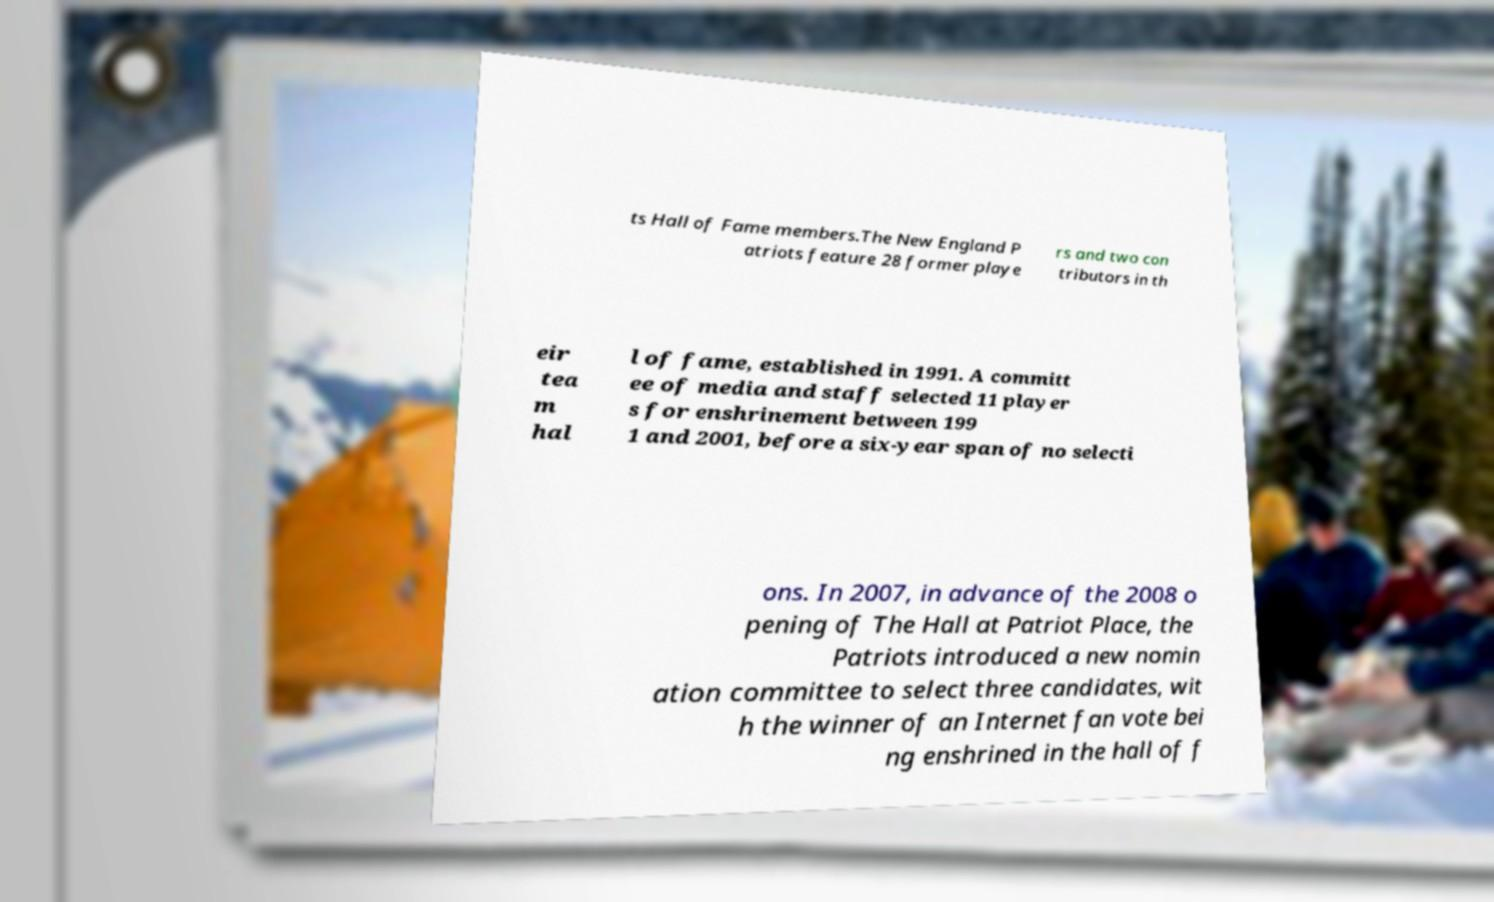What messages or text are displayed in this image? I need them in a readable, typed format. ts Hall of Fame members.The New England P atriots feature 28 former playe rs and two con tributors in th eir tea m hal l of fame, established in 1991. A committ ee of media and staff selected 11 player s for enshrinement between 199 1 and 2001, before a six-year span of no selecti ons. In 2007, in advance of the 2008 o pening of The Hall at Patriot Place, the Patriots introduced a new nomin ation committee to select three candidates, wit h the winner of an Internet fan vote bei ng enshrined in the hall of f 